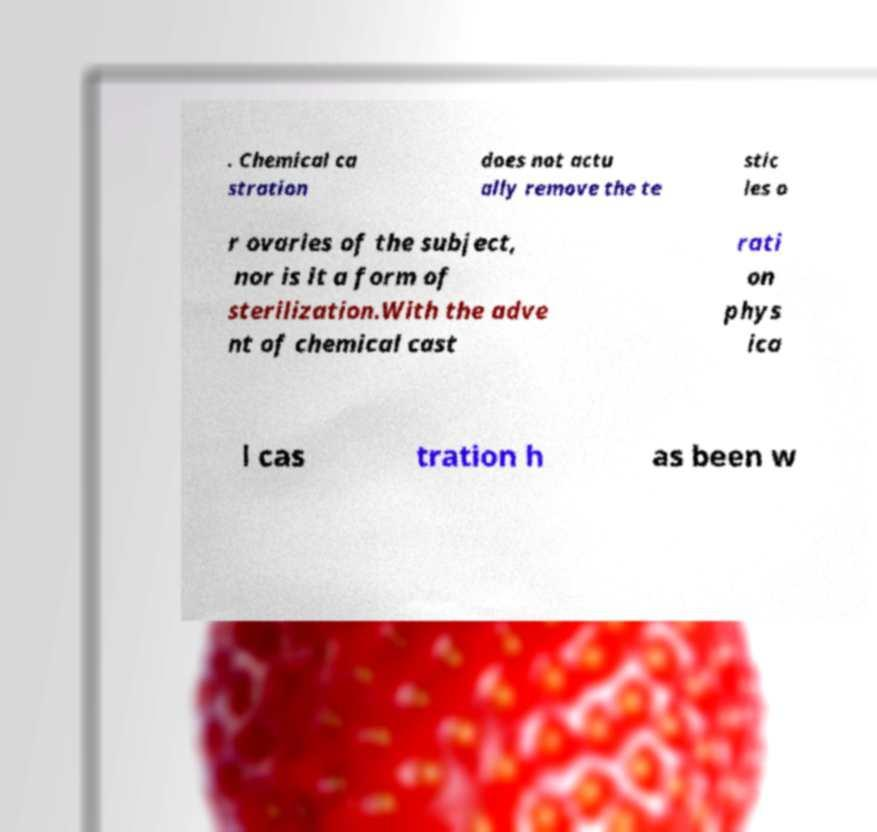Can you read and provide the text displayed in the image?This photo seems to have some interesting text. Can you extract and type it out for me? . Chemical ca stration does not actu ally remove the te stic les o r ovaries of the subject, nor is it a form of sterilization.With the adve nt of chemical cast rati on phys ica l cas tration h as been w 